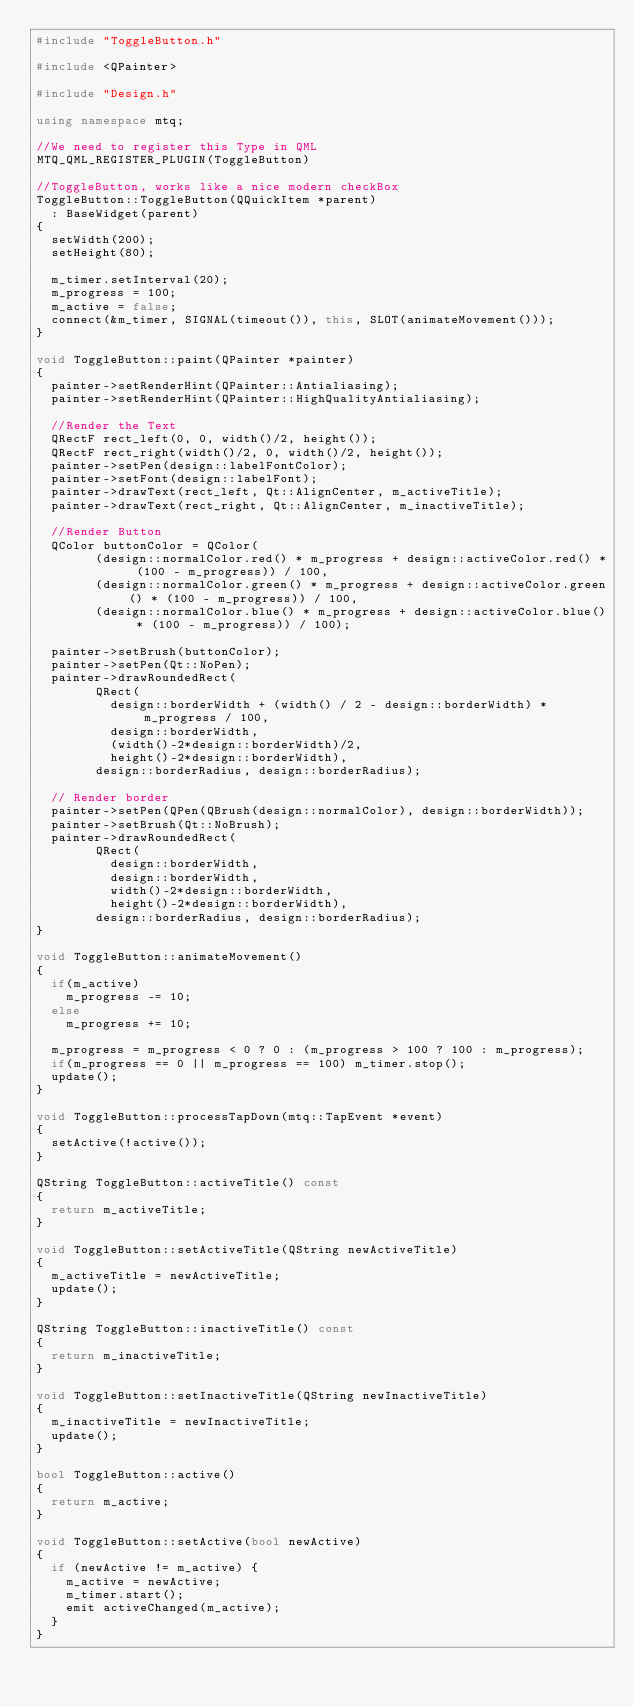<code> <loc_0><loc_0><loc_500><loc_500><_C++_>#include "ToggleButton.h"

#include <QPainter>

#include "Design.h"

using namespace mtq;

//We need to register this Type in QML
MTQ_QML_REGISTER_PLUGIN(ToggleButton)

//ToggleButton, works like a nice modern checkBox
ToggleButton::ToggleButton(QQuickItem *parent)
	: BaseWidget(parent)
{
	setWidth(200);
	setHeight(80);

	m_timer.setInterval(20);
	m_progress = 100;
	m_active = false;
	connect(&m_timer, SIGNAL(timeout()), this, SLOT(animateMovement()));
}

void ToggleButton::paint(QPainter *painter)
{
	painter->setRenderHint(QPainter::Antialiasing);
	painter->setRenderHint(QPainter::HighQualityAntialiasing);

	//Render the Text
	QRectF rect_left(0, 0, width()/2, height());
	QRectF rect_right(width()/2, 0, width()/2, height());
	painter->setPen(design::labelFontColor);
	painter->setFont(design::labelFont);
	painter->drawText(rect_left, Qt::AlignCenter, m_activeTitle);
	painter->drawText(rect_right, Qt::AlignCenter, m_inactiveTitle);

	//Render Button
	QColor buttonColor = QColor(
				(design::normalColor.red() * m_progress + design::activeColor.red() * (100 - m_progress)) / 100,
				(design::normalColor.green() * m_progress + design::activeColor.green() * (100 - m_progress)) / 100,
				(design::normalColor.blue() * m_progress + design::activeColor.blue() * (100 - m_progress)) / 100);

	painter->setBrush(buttonColor);
	painter->setPen(Qt::NoPen);
	painter->drawRoundedRect(
				QRect(
					design::borderWidth + (width() / 2 - design::borderWidth) * m_progress / 100,
					design::borderWidth,
					(width()-2*design::borderWidth)/2,
					height()-2*design::borderWidth),
				design::borderRadius, design::borderRadius);

	// Render border
	painter->setPen(QPen(QBrush(design::normalColor), design::borderWidth));
	painter->setBrush(Qt::NoBrush);
	painter->drawRoundedRect(
				QRect(
					design::borderWidth,
					design::borderWidth,
					width()-2*design::borderWidth,
					height()-2*design::borderWidth),
				design::borderRadius, design::borderRadius);
}

void ToggleButton::animateMovement()
{
	if(m_active)
		m_progress -= 10;
	else
		m_progress += 10;

	m_progress = m_progress < 0 ? 0 : (m_progress > 100 ? 100 : m_progress);
	if(m_progress == 0 || m_progress == 100) m_timer.stop();
	update();
}

void ToggleButton::processTapDown(mtq::TapEvent *event)
{
	setActive(!active());
}

QString ToggleButton::activeTitle() const
{
	return m_activeTitle;
}

void ToggleButton::setActiveTitle(QString newActiveTitle)
{
	m_activeTitle = newActiveTitle;
	update();
}

QString ToggleButton::inactiveTitle() const
{
	return m_inactiveTitle;
}

void ToggleButton::setInactiveTitle(QString newInactiveTitle)
{
	m_inactiveTitle = newInactiveTitle;
	update();
}

bool ToggleButton::active()
{
	return m_active;
}

void ToggleButton::setActive(bool newActive)
{
	if (newActive != m_active) {
		m_active = newActive;
		m_timer.start();
		emit activeChanged(m_active);
	}
}
</code> 